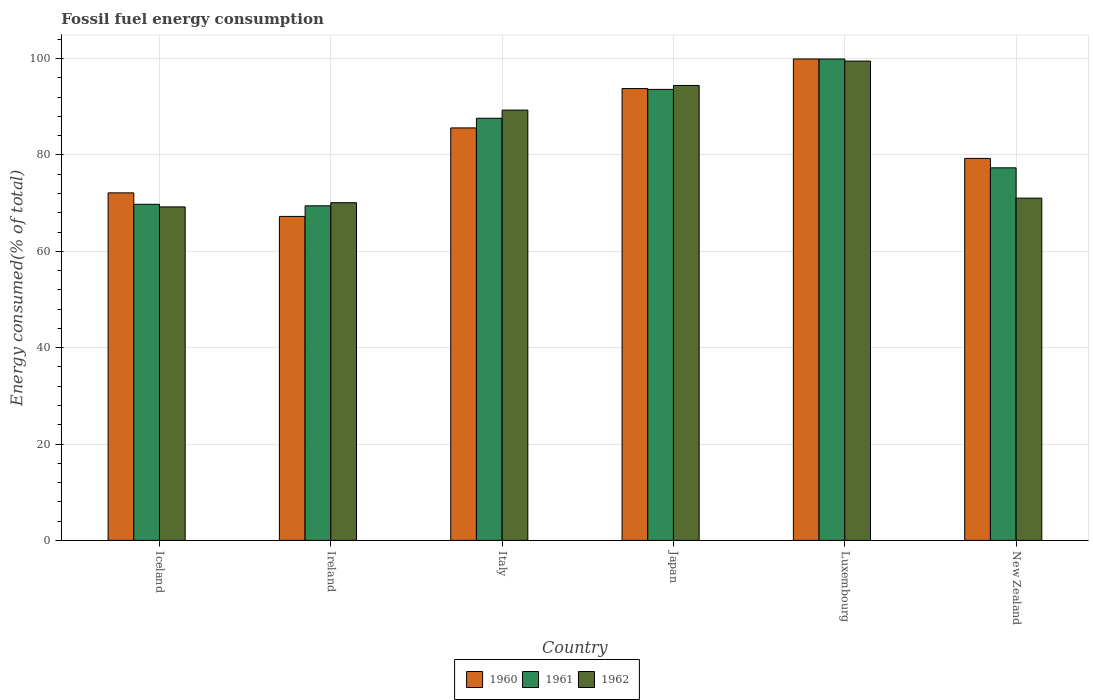Are the number of bars on each tick of the X-axis equal?
Provide a succinct answer. Yes. How many bars are there on the 6th tick from the left?
Ensure brevity in your answer.  3. How many bars are there on the 1st tick from the right?
Provide a short and direct response. 3. What is the label of the 5th group of bars from the left?
Give a very brief answer. Luxembourg. In how many cases, is the number of bars for a given country not equal to the number of legend labels?
Make the answer very short. 0. What is the percentage of energy consumed in 1960 in Luxembourg?
Ensure brevity in your answer.  99.92. Across all countries, what is the maximum percentage of energy consumed in 1960?
Keep it short and to the point. 99.92. Across all countries, what is the minimum percentage of energy consumed in 1961?
Your answer should be compact. 69.44. In which country was the percentage of energy consumed in 1961 maximum?
Ensure brevity in your answer.  Luxembourg. In which country was the percentage of energy consumed in 1960 minimum?
Provide a short and direct response. Ireland. What is the total percentage of energy consumed in 1961 in the graph?
Provide a short and direct response. 497.66. What is the difference between the percentage of energy consumed in 1962 in Iceland and that in New Zealand?
Make the answer very short. -1.82. What is the difference between the percentage of energy consumed in 1961 in New Zealand and the percentage of energy consumed in 1962 in Luxembourg?
Provide a succinct answer. -22.16. What is the average percentage of energy consumed in 1960 per country?
Your answer should be compact. 82.99. What is the difference between the percentage of energy consumed of/in 1961 and percentage of energy consumed of/in 1962 in Italy?
Offer a terse response. -1.69. What is the ratio of the percentage of energy consumed in 1960 in Iceland to that in Italy?
Provide a short and direct response. 0.84. Is the percentage of energy consumed in 1960 in Italy less than that in Luxembourg?
Your answer should be very brief. Yes. What is the difference between the highest and the second highest percentage of energy consumed in 1960?
Ensure brevity in your answer.  14.31. What is the difference between the highest and the lowest percentage of energy consumed in 1962?
Give a very brief answer. 30.27. What does the 3rd bar from the right in Ireland represents?
Your answer should be compact. 1960. How many bars are there?
Offer a very short reply. 18. How many countries are there in the graph?
Ensure brevity in your answer.  6. What is the difference between two consecutive major ticks on the Y-axis?
Give a very brief answer. 20. Does the graph contain any zero values?
Your answer should be very brief. No. Does the graph contain grids?
Offer a very short reply. Yes. Where does the legend appear in the graph?
Provide a succinct answer. Bottom center. How many legend labels are there?
Your answer should be compact. 3. What is the title of the graph?
Provide a short and direct response. Fossil fuel energy consumption. What is the label or title of the Y-axis?
Your answer should be very brief. Energy consumed(% of total). What is the Energy consumed(% of total) in 1960 in Iceland?
Your response must be concise. 72.13. What is the Energy consumed(% of total) in 1961 in Iceland?
Your answer should be compact. 69.76. What is the Energy consumed(% of total) in 1962 in Iceland?
Provide a succinct answer. 69.22. What is the Energy consumed(% of total) in 1960 in Ireland?
Provide a short and direct response. 67.24. What is the Energy consumed(% of total) of 1961 in Ireland?
Offer a very short reply. 69.44. What is the Energy consumed(% of total) of 1962 in Ireland?
Offer a terse response. 70.09. What is the Energy consumed(% of total) in 1960 in Italy?
Your answer should be very brief. 85.61. What is the Energy consumed(% of total) in 1961 in Italy?
Your answer should be compact. 87.62. What is the Energy consumed(% of total) in 1962 in Italy?
Your response must be concise. 89.31. What is the Energy consumed(% of total) in 1960 in Japan?
Give a very brief answer. 93.78. What is the Energy consumed(% of total) of 1961 in Japan?
Give a very brief answer. 93.6. What is the Energy consumed(% of total) in 1962 in Japan?
Your answer should be compact. 94.42. What is the Energy consumed(% of total) in 1960 in Luxembourg?
Offer a terse response. 99.92. What is the Energy consumed(% of total) of 1961 in Luxembourg?
Offer a very short reply. 99.91. What is the Energy consumed(% of total) of 1962 in Luxembourg?
Offer a very short reply. 99.49. What is the Energy consumed(% of total) of 1960 in New Zealand?
Your answer should be compact. 79.28. What is the Energy consumed(% of total) of 1961 in New Zealand?
Provide a short and direct response. 77.33. What is the Energy consumed(% of total) of 1962 in New Zealand?
Make the answer very short. 71.04. Across all countries, what is the maximum Energy consumed(% of total) of 1960?
Your answer should be very brief. 99.92. Across all countries, what is the maximum Energy consumed(% of total) of 1961?
Give a very brief answer. 99.91. Across all countries, what is the maximum Energy consumed(% of total) in 1962?
Offer a very short reply. 99.49. Across all countries, what is the minimum Energy consumed(% of total) of 1960?
Your response must be concise. 67.24. Across all countries, what is the minimum Energy consumed(% of total) in 1961?
Make the answer very short. 69.44. Across all countries, what is the minimum Energy consumed(% of total) in 1962?
Your answer should be compact. 69.22. What is the total Energy consumed(% of total) in 1960 in the graph?
Your response must be concise. 497.96. What is the total Energy consumed(% of total) of 1961 in the graph?
Give a very brief answer. 497.66. What is the total Energy consumed(% of total) in 1962 in the graph?
Your response must be concise. 493.56. What is the difference between the Energy consumed(% of total) in 1960 in Iceland and that in Ireland?
Make the answer very short. 4.89. What is the difference between the Energy consumed(% of total) in 1961 in Iceland and that in Ireland?
Your answer should be very brief. 0.32. What is the difference between the Energy consumed(% of total) in 1962 in Iceland and that in Ireland?
Provide a short and direct response. -0.87. What is the difference between the Energy consumed(% of total) of 1960 in Iceland and that in Italy?
Your answer should be very brief. -13.48. What is the difference between the Energy consumed(% of total) of 1961 in Iceland and that in Italy?
Offer a very short reply. -17.86. What is the difference between the Energy consumed(% of total) in 1962 in Iceland and that in Italy?
Your answer should be compact. -20.09. What is the difference between the Energy consumed(% of total) in 1960 in Iceland and that in Japan?
Your answer should be compact. -21.65. What is the difference between the Energy consumed(% of total) of 1961 in Iceland and that in Japan?
Offer a very short reply. -23.85. What is the difference between the Energy consumed(% of total) in 1962 in Iceland and that in Japan?
Your answer should be compact. -25.2. What is the difference between the Energy consumed(% of total) in 1960 in Iceland and that in Luxembourg?
Your answer should be compact. -27.8. What is the difference between the Energy consumed(% of total) in 1961 in Iceland and that in Luxembourg?
Offer a terse response. -30.16. What is the difference between the Energy consumed(% of total) of 1962 in Iceland and that in Luxembourg?
Give a very brief answer. -30.27. What is the difference between the Energy consumed(% of total) of 1960 in Iceland and that in New Zealand?
Ensure brevity in your answer.  -7.15. What is the difference between the Energy consumed(% of total) of 1961 in Iceland and that in New Zealand?
Make the answer very short. -7.57. What is the difference between the Energy consumed(% of total) of 1962 in Iceland and that in New Zealand?
Your response must be concise. -1.82. What is the difference between the Energy consumed(% of total) of 1960 in Ireland and that in Italy?
Ensure brevity in your answer.  -18.37. What is the difference between the Energy consumed(% of total) in 1961 in Ireland and that in Italy?
Provide a short and direct response. -18.18. What is the difference between the Energy consumed(% of total) of 1962 in Ireland and that in Italy?
Your answer should be very brief. -19.23. What is the difference between the Energy consumed(% of total) in 1960 in Ireland and that in Japan?
Your answer should be very brief. -26.53. What is the difference between the Energy consumed(% of total) in 1961 in Ireland and that in Japan?
Provide a succinct answer. -24.16. What is the difference between the Energy consumed(% of total) of 1962 in Ireland and that in Japan?
Keep it short and to the point. -24.34. What is the difference between the Energy consumed(% of total) in 1960 in Ireland and that in Luxembourg?
Provide a short and direct response. -32.68. What is the difference between the Energy consumed(% of total) in 1961 in Ireland and that in Luxembourg?
Provide a succinct answer. -30.47. What is the difference between the Energy consumed(% of total) of 1962 in Ireland and that in Luxembourg?
Ensure brevity in your answer.  -29.4. What is the difference between the Energy consumed(% of total) of 1960 in Ireland and that in New Zealand?
Provide a short and direct response. -12.04. What is the difference between the Energy consumed(% of total) in 1961 in Ireland and that in New Zealand?
Provide a succinct answer. -7.89. What is the difference between the Energy consumed(% of total) in 1962 in Ireland and that in New Zealand?
Your response must be concise. -0.95. What is the difference between the Energy consumed(% of total) of 1960 in Italy and that in Japan?
Provide a succinct answer. -8.17. What is the difference between the Energy consumed(% of total) of 1961 in Italy and that in Japan?
Your answer should be very brief. -5.99. What is the difference between the Energy consumed(% of total) in 1962 in Italy and that in Japan?
Ensure brevity in your answer.  -5.11. What is the difference between the Energy consumed(% of total) of 1960 in Italy and that in Luxembourg?
Your answer should be compact. -14.31. What is the difference between the Energy consumed(% of total) of 1961 in Italy and that in Luxembourg?
Keep it short and to the point. -12.3. What is the difference between the Energy consumed(% of total) of 1962 in Italy and that in Luxembourg?
Offer a terse response. -10.18. What is the difference between the Energy consumed(% of total) in 1960 in Italy and that in New Zealand?
Ensure brevity in your answer.  6.33. What is the difference between the Energy consumed(% of total) in 1961 in Italy and that in New Zealand?
Your answer should be very brief. 10.29. What is the difference between the Energy consumed(% of total) in 1962 in Italy and that in New Zealand?
Keep it short and to the point. 18.27. What is the difference between the Energy consumed(% of total) in 1960 in Japan and that in Luxembourg?
Provide a succinct answer. -6.15. What is the difference between the Energy consumed(% of total) in 1961 in Japan and that in Luxembourg?
Your response must be concise. -6.31. What is the difference between the Energy consumed(% of total) in 1962 in Japan and that in Luxembourg?
Make the answer very short. -5.07. What is the difference between the Energy consumed(% of total) in 1960 in Japan and that in New Zealand?
Ensure brevity in your answer.  14.5. What is the difference between the Energy consumed(% of total) in 1961 in Japan and that in New Zealand?
Keep it short and to the point. 16.28. What is the difference between the Energy consumed(% of total) of 1962 in Japan and that in New Zealand?
Your response must be concise. 23.38. What is the difference between the Energy consumed(% of total) in 1960 in Luxembourg and that in New Zealand?
Provide a short and direct response. 20.65. What is the difference between the Energy consumed(% of total) in 1961 in Luxembourg and that in New Zealand?
Ensure brevity in your answer.  22.58. What is the difference between the Energy consumed(% of total) in 1962 in Luxembourg and that in New Zealand?
Make the answer very short. 28.45. What is the difference between the Energy consumed(% of total) in 1960 in Iceland and the Energy consumed(% of total) in 1961 in Ireland?
Offer a very short reply. 2.69. What is the difference between the Energy consumed(% of total) in 1960 in Iceland and the Energy consumed(% of total) in 1962 in Ireland?
Your answer should be very brief. 2.04. What is the difference between the Energy consumed(% of total) of 1961 in Iceland and the Energy consumed(% of total) of 1962 in Ireland?
Make the answer very short. -0.33. What is the difference between the Energy consumed(% of total) in 1960 in Iceland and the Energy consumed(% of total) in 1961 in Italy?
Offer a terse response. -15.49. What is the difference between the Energy consumed(% of total) in 1960 in Iceland and the Energy consumed(% of total) in 1962 in Italy?
Ensure brevity in your answer.  -17.18. What is the difference between the Energy consumed(% of total) of 1961 in Iceland and the Energy consumed(% of total) of 1962 in Italy?
Your response must be concise. -19.55. What is the difference between the Energy consumed(% of total) of 1960 in Iceland and the Energy consumed(% of total) of 1961 in Japan?
Provide a succinct answer. -21.48. What is the difference between the Energy consumed(% of total) of 1960 in Iceland and the Energy consumed(% of total) of 1962 in Japan?
Offer a terse response. -22.29. What is the difference between the Energy consumed(% of total) of 1961 in Iceland and the Energy consumed(% of total) of 1962 in Japan?
Provide a short and direct response. -24.66. What is the difference between the Energy consumed(% of total) in 1960 in Iceland and the Energy consumed(% of total) in 1961 in Luxembourg?
Offer a very short reply. -27.78. What is the difference between the Energy consumed(% of total) of 1960 in Iceland and the Energy consumed(% of total) of 1962 in Luxembourg?
Make the answer very short. -27.36. What is the difference between the Energy consumed(% of total) in 1961 in Iceland and the Energy consumed(% of total) in 1962 in Luxembourg?
Offer a terse response. -29.73. What is the difference between the Energy consumed(% of total) of 1960 in Iceland and the Energy consumed(% of total) of 1961 in New Zealand?
Offer a very short reply. -5.2. What is the difference between the Energy consumed(% of total) in 1960 in Iceland and the Energy consumed(% of total) in 1962 in New Zealand?
Offer a very short reply. 1.09. What is the difference between the Energy consumed(% of total) of 1961 in Iceland and the Energy consumed(% of total) of 1962 in New Zealand?
Give a very brief answer. -1.28. What is the difference between the Energy consumed(% of total) in 1960 in Ireland and the Energy consumed(% of total) in 1961 in Italy?
Your answer should be very brief. -20.38. What is the difference between the Energy consumed(% of total) of 1960 in Ireland and the Energy consumed(% of total) of 1962 in Italy?
Provide a short and direct response. -22.07. What is the difference between the Energy consumed(% of total) of 1961 in Ireland and the Energy consumed(% of total) of 1962 in Italy?
Make the answer very short. -19.87. What is the difference between the Energy consumed(% of total) of 1960 in Ireland and the Energy consumed(% of total) of 1961 in Japan?
Offer a terse response. -26.36. What is the difference between the Energy consumed(% of total) in 1960 in Ireland and the Energy consumed(% of total) in 1962 in Japan?
Provide a succinct answer. -27.18. What is the difference between the Energy consumed(% of total) of 1961 in Ireland and the Energy consumed(% of total) of 1962 in Japan?
Make the answer very short. -24.98. What is the difference between the Energy consumed(% of total) of 1960 in Ireland and the Energy consumed(% of total) of 1961 in Luxembourg?
Your answer should be compact. -32.67. What is the difference between the Energy consumed(% of total) of 1960 in Ireland and the Energy consumed(% of total) of 1962 in Luxembourg?
Provide a short and direct response. -32.25. What is the difference between the Energy consumed(% of total) in 1961 in Ireland and the Energy consumed(% of total) in 1962 in Luxembourg?
Give a very brief answer. -30.05. What is the difference between the Energy consumed(% of total) of 1960 in Ireland and the Energy consumed(% of total) of 1961 in New Zealand?
Give a very brief answer. -10.09. What is the difference between the Energy consumed(% of total) in 1960 in Ireland and the Energy consumed(% of total) in 1962 in New Zealand?
Give a very brief answer. -3.79. What is the difference between the Energy consumed(% of total) in 1961 in Ireland and the Energy consumed(% of total) in 1962 in New Zealand?
Your response must be concise. -1.6. What is the difference between the Energy consumed(% of total) in 1960 in Italy and the Energy consumed(% of total) in 1961 in Japan?
Offer a terse response. -7.99. What is the difference between the Energy consumed(% of total) in 1960 in Italy and the Energy consumed(% of total) in 1962 in Japan?
Ensure brevity in your answer.  -8.81. What is the difference between the Energy consumed(% of total) in 1961 in Italy and the Energy consumed(% of total) in 1962 in Japan?
Offer a terse response. -6.8. What is the difference between the Energy consumed(% of total) of 1960 in Italy and the Energy consumed(% of total) of 1961 in Luxembourg?
Your answer should be very brief. -14.3. What is the difference between the Energy consumed(% of total) of 1960 in Italy and the Energy consumed(% of total) of 1962 in Luxembourg?
Make the answer very short. -13.88. What is the difference between the Energy consumed(% of total) of 1961 in Italy and the Energy consumed(% of total) of 1962 in Luxembourg?
Offer a very short reply. -11.87. What is the difference between the Energy consumed(% of total) of 1960 in Italy and the Energy consumed(% of total) of 1961 in New Zealand?
Your response must be concise. 8.28. What is the difference between the Energy consumed(% of total) in 1960 in Italy and the Energy consumed(% of total) in 1962 in New Zealand?
Provide a short and direct response. 14.57. What is the difference between the Energy consumed(% of total) of 1961 in Italy and the Energy consumed(% of total) of 1962 in New Zealand?
Your response must be concise. 16.58. What is the difference between the Energy consumed(% of total) of 1960 in Japan and the Energy consumed(% of total) of 1961 in Luxembourg?
Your answer should be very brief. -6.14. What is the difference between the Energy consumed(% of total) in 1960 in Japan and the Energy consumed(% of total) in 1962 in Luxembourg?
Ensure brevity in your answer.  -5.71. What is the difference between the Energy consumed(% of total) of 1961 in Japan and the Energy consumed(% of total) of 1962 in Luxembourg?
Offer a terse response. -5.88. What is the difference between the Energy consumed(% of total) in 1960 in Japan and the Energy consumed(% of total) in 1961 in New Zealand?
Offer a very short reply. 16.45. What is the difference between the Energy consumed(% of total) of 1960 in Japan and the Energy consumed(% of total) of 1962 in New Zealand?
Offer a very short reply. 22.74. What is the difference between the Energy consumed(% of total) in 1961 in Japan and the Energy consumed(% of total) in 1962 in New Zealand?
Offer a very short reply. 22.57. What is the difference between the Energy consumed(% of total) in 1960 in Luxembourg and the Energy consumed(% of total) in 1961 in New Zealand?
Keep it short and to the point. 22.6. What is the difference between the Energy consumed(% of total) of 1960 in Luxembourg and the Energy consumed(% of total) of 1962 in New Zealand?
Give a very brief answer. 28.89. What is the difference between the Energy consumed(% of total) in 1961 in Luxembourg and the Energy consumed(% of total) in 1962 in New Zealand?
Offer a terse response. 28.88. What is the average Energy consumed(% of total) in 1960 per country?
Provide a short and direct response. 82.99. What is the average Energy consumed(% of total) in 1961 per country?
Offer a very short reply. 82.94. What is the average Energy consumed(% of total) of 1962 per country?
Provide a short and direct response. 82.26. What is the difference between the Energy consumed(% of total) in 1960 and Energy consumed(% of total) in 1961 in Iceland?
Provide a short and direct response. 2.37. What is the difference between the Energy consumed(% of total) of 1960 and Energy consumed(% of total) of 1962 in Iceland?
Keep it short and to the point. 2.91. What is the difference between the Energy consumed(% of total) of 1961 and Energy consumed(% of total) of 1962 in Iceland?
Your answer should be very brief. 0.54. What is the difference between the Energy consumed(% of total) of 1960 and Energy consumed(% of total) of 1961 in Ireland?
Your response must be concise. -2.2. What is the difference between the Energy consumed(% of total) in 1960 and Energy consumed(% of total) in 1962 in Ireland?
Your answer should be very brief. -2.84. What is the difference between the Energy consumed(% of total) in 1961 and Energy consumed(% of total) in 1962 in Ireland?
Offer a very short reply. -0.65. What is the difference between the Energy consumed(% of total) in 1960 and Energy consumed(% of total) in 1961 in Italy?
Your answer should be very brief. -2.01. What is the difference between the Energy consumed(% of total) in 1960 and Energy consumed(% of total) in 1962 in Italy?
Offer a very short reply. -3.7. What is the difference between the Energy consumed(% of total) in 1961 and Energy consumed(% of total) in 1962 in Italy?
Ensure brevity in your answer.  -1.69. What is the difference between the Energy consumed(% of total) of 1960 and Energy consumed(% of total) of 1961 in Japan?
Give a very brief answer. 0.17. What is the difference between the Energy consumed(% of total) in 1960 and Energy consumed(% of total) in 1962 in Japan?
Offer a very short reply. -0.64. What is the difference between the Energy consumed(% of total) of 1961 and Energy consumed(% of total) of 1962 in Japan?
Your answer should be very brief. -0.82. What is the difference between the Energy consumed(% of total) of 1960 and Energy consumed(% of total) of 1961 in Luxembourg?
Ensure brevity in your answer.  0.01. What is the difference between the Energy consumed(% of total) of 1960 and Energy consumed(% of total) of 1962 in Luxembourg?
Your answer should be compact. 0.44. What is the difference between the Energy consumed(% of total) in 1961 and Energy consumed(% of total) in 1962 in Luxembourg?
Your answer should be very brief. 0.42. What is the difference between the Energy consumed(% of total) in 1960 and Energy consumed(% of total) in 1961 in New Zealand?
Ensure brevity in your answer.  1.95. What is the difference between the Energy consumed(% of total) of 1960 and Energy consumed(% of total) of 1962 in New Zealand?
Keep it short and to the point. 8.24. What is the difference between the Energy consumed(% of total) in 1961 and Energy consumed(% of total) in 1962 in New Zealand?
Your response must be concise. 6.29. What is the ratio of the Energy consumed(% of total) in 1960 in Iceland to that in Ireland?
Your answer should be compact. 1.07. What is the ratio of the Energy consumed(% of total) of 1961 in Iceland to that in Ireland?
Offer a terse response. 1. What is the ratio of the Energy consumed(% of total) of 1962 in Iceland to that in Ireland?
Keep it short and to the point. 0.99. What is the ratio of the Energy consumed(% of total) of 1960 in Iceland to that in Italy?
Offer a terse response. 0.84. What is the ratio of the Energy consumed(% of total) in 1961 in Iceland to that in Italy?
Offer a very short reply. 0.8. What is the ratio of the Energy consumed(% of total) of 1962 in Iceland to that in Italy?
Offer a terse response. 0.78. What is the ratio of the Energy consumed(% of total) of 1960 in Iceland to that in Japan?
Offer a very short reply. 0.77. What is the ratio of the Energy consumed(% of total) of 1961 in Iceland to that in Japan?
Offer a terse response. 0.75. What is the ratio of the Energy consumed(% of total) of 1962 in Iceland to that in Japan?
Your response must be concise. 0.73. What is the ratio of the Energy consumed(% of total) of 1960 in Iceland to that in Luxembourg?
Offer a terse response. 0.72. What is the ratio of the Energy consumed(% of total) in 1961 in Iceland to that in Luxembourg?
Offer a terse response. 0.7. What is the ratio of the Energy consumed(% of total) of 1962 in Iceland to that in Luxembourg?
Make the answer very short. 0.7. What is the ratio of the Energy consumed(% of total) in 1960 in Iceland to that in New Zealand?
Offer a very short reply. 0.91. What is the ratio of the Energy consumed(% of total) of 1961 in Iceland to that in New Zealand?
Make the answer very short. 0.9. What is the ratio of the Energy consumed(% of total) of 1962 in Iceland to that in New Zealand?
Ensure brevity in your answer.  0.97. What is the ratio of the Energy consumed(% of total) in 1960 in Ireland to that in Italy?
Provide a short and direct response. 0.79. What is the ratio of the Energy consumed(% of total) in 1961 in Ireland to that in Italy?
Make the answer very short. 0.79. What is the ratio of the Energy consumed(% of total) of 1962 in Ireland to that in Italy?
Offer a very short reply. 0.78. What is the ratio of the Energy consumed(% of total) of 1960 in Ireland to that in Japan?
Give a very brief answer. 0.72. What is the ratio of the Energy consumed(% of total) in 1961 in Ireland to that in Japan?
Your answer should be very brief. 0.74. What is the ratio of the Energy consumed(% of total) in 1962 in Ireland to that in Japan?
Make the answer very short. 0.74. What is the ratio of the Energy consumed(% of total) of 1960 in Ireland to that in Luxembourg?
Provide a short and direct response. 0.67. What is the ratio of the Energy consumed(% of total) in 1961 in Ireland to that in Luxembourg?
Provide a succinct answer. 0.69. What is the ratio of the Energy consumed(% of total) in 1962 in Ireland to that in Luxembourg?
Give a very brief answer. 0.7. What is the ratio of the Energy consumed(% of total) in 1960 in Ireland to that in New Zealand?
Your answer should be very brief. 0.85. What is the ratio of the Energy consumed(% of total) in 1961 in Ireland to that in New Zealand?
Provide a succinct answer. 0.9. What is the ratio of the Energy consumed(% of total) in 1962 in Ireland to that in New Zealand?
Give a very brief answer. 0.99. What is the ratio of the Energy consumed(% of total) in 1960 in Italy to that in Japan?
Make the answer very short. 0.91. What is the ratio of the Energy consumed(% of total) of 1961 in Italy to that in Japan?
Your answer should be compact. 0.94. What is the ratio of the Energy consumed(% of total) in 1962 in Italy to that in Japan?
Provide a succinct answer. 0.95. What is the ratio of the Energy consumed(% of total) in 1960 in Italy to that in Luxembourg?
Give a very brief answer. 0.86. What is the ratio of the Energy consumed(% of total) in 1961 in Italy to that in Luxembourg?
Keep it short and to the point. 0.88. What is the ratio of the Energy consumed(% of total) of 1962 in Italy to that in Luxembourg?
Provide a short and direct response. 0.9. What is the ratio of the Energy consumed(% of total) in 1960 in Italy to that in New Zealand?
Ensure brevity in your answer.  1.08. What is the ratio of the Energy consumed(% of total) in 1961 in Italy to that in New Zealand?
Your answer should be very brief. 1.13. What is the ratio of the Energy consumed(% of total) of 1962 in Italy to that in New Zealand?
Ensure brevity in your answer.  1.26. What is the ratio of the Energy consumed(% of total) in 1960 in Japan to that in Luxembourg?
Provide a succinct answer. 0.94. What is the ratio of the Energy consumed(% of total) in 1961 in Japan to that in Luxembourg?
Your response must be concise. 0.94. What is the ratio of the Energy consumed(% of total) in 1962 in Japan to that in Luxembourg?
Your answer should be compact. 0.95. What is the ratio of the Energy consumed(% of total) of 1960 in Japan to that in New Zealand?
Your response must be concise. 1.18. What is the ratio of the Energy consumed(% of total) of 1961 in Japan to that in New Zealand?
Keep it short and to the point. 1.21. What is the ratio of the Energy consumed(% of total) of 1962 in Japan to that in New Zealand?
Give a very brief answer. 1.33. What is the ratio of the Energy consumed(% of total) of 1960 in Luxembourg to that in New Zealand?
Make the answer very short. 1.26. What is the ratio of the Energy consumed(% of total) of 1961 in Luxembourg to that in New Zealand?
Your answer should be compact. 1.29. What is the ratio of the Energy consumed(% of total) in 1962 in Luxembourg to that in New Zealand?
Ensure brevity in your answer.  1.4. What is the difference between the highest and the second highest Energy consumed(% of total) in 1960?
Make the answer very short. 6.15. What is the difference between the highest and the second highest Energy consumed(% of total) in 1961?
Offer a very short reply. 6.31. What is the difference between the highest and the second highest Energy consumed(% of total) of 1962?
Your response must be concise. 5.07. What is the difference between the highest and the lowest Energy consumed(% of total) of 1960?
Your response must be concise. 32.68. What is the difference between the highest and the lowest Energy consumed(% of total) of 1961?
Make the answer very short. 30.47. What is the difference between the highest and the lowest Energy consumed(% of total) in 1962?
Your response must be concise. 30.27. 